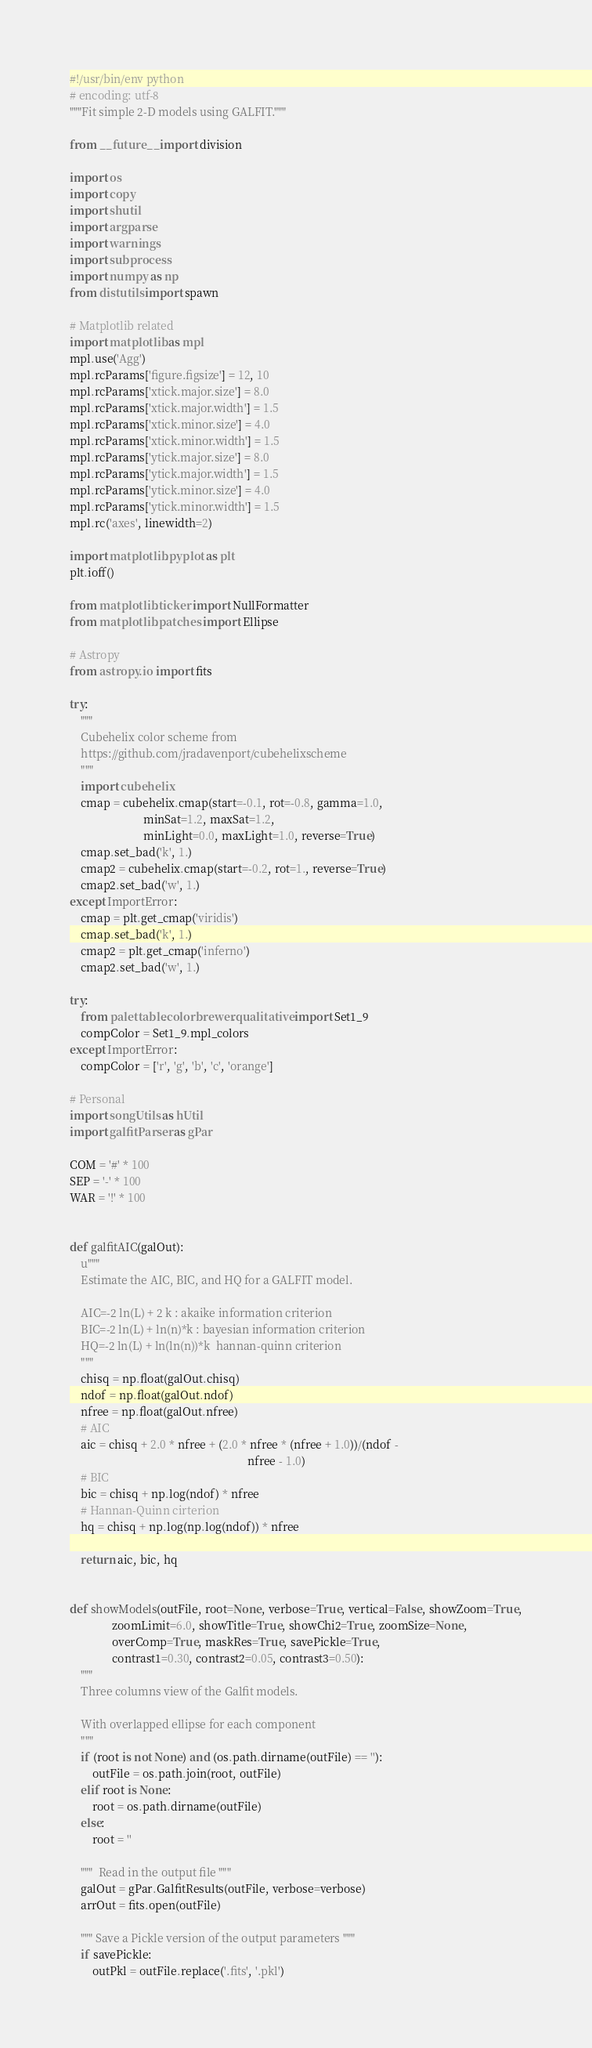<code> <loc_0><loc_0><loc_500><loc_500><_Python_>#!/usr/bin/env python
# encoding: utf-8
"""Fit simple 2-D models using GALFIT."""

from __future__ import division

import os
import copy
import shutil
import argparse
import warnings
import subprocess
import numpy as np
from distutils import spawn

# Matplotlib related
import matplotlib as mpl
mpl.use('Agg')
mpl.rcParams['figure.figsize'] = 12, 10
mpl.rcParams['xtick.major.size'] = 8.0
mpl.rcParams['xtick.major.width'] = 1.5
mpl.rcParams['xtick.minor.size'] = 4.0
mpl.rcParams['xtick.minor.width'] = 1.5
mpl.rcParams['ytick.major.size'] = 8.0
mpl.rcParams['ytick.major.width'] = 1.5
mpl.rcParams['ytick.minor.size'] = 4.0
mpl.rcParams['ytick.minor.width'] = 1.5
mpl.rc('axes', linewidth=2)

import matplotlib.pyplot as plt
plt.ioff()

from matplotlib.ticker import NullFormatter
from matplotlib.patches import Ellipse

# Astropy
from astropy.io import fits

try:
    """
    Cubehelix color scheme from
    https://github.com/jradavenport/cubehelixscheme
    """
    import cubehelix
    cmap = cubehelix.cmap(start=-0.1, rot=-0.8, gamma=1.0,
                          minSat=1.2, maxSat=1.2,
                          minLight=0.0, maxLight=1.0, reverse=True)
    cmap.set_bad('k', 1.)
    cmap2 = cubehelix.cmap(start=-0.2, rot=1., reverse=True)
    cmap2.set_bad('w', 1.)
except ImportError:
    cmap = plt.get_cmap('viridis')
    cmap.set_bad('k', 1.)
    cmap2 = plt.get_cmap('inferno')
    cmap2.set_bad('w', 1.)

try:
    from palettable.colorbrewer.qualitative import Set1_9
    compColor = Set1_9.mpl_colors
except ImportError:
    compColor = ['r', 'g', 'b', 'c', 'orange']

# Personal
import songUtils as hUtil
import galfitParser as gPar

COM = '#' * 100
SEP = '-' * 100
WAR = '!' * 100


def galfitAIC(galOut):
    u"""
    Estimate the AIC, BIC, and HQ for a GALFIT model.

    AIC=-2 ln(L) + 2 k : akaike information criterion
    BIC=-2 ln(L) + ln(n)*k : bayesian information criterion
    HQ=-2 ln(L) + ln(ln(n))*k  hannan-quinn criterion
    """
    chisq = np.float(galOut.chisq)
    ndof = np.float(galOut.ndof)
    nfree = np.float(galOut.nfree)
    # AIC
    aic = chisq + 2.0 * nfree + (2.0 * nfree * (nfree + 1.0))/(ndof -
                                                               nfree - 1.0)
    # BIC
    bic = chisq + np.log(ndof) * nfree
    # Hannan-Quinn cirterion
    hq = chisq + np.log(np.log(ndof)) * nfree

    return aic, bic, hq


def showModels(outFile, root=None, verbose=True, vertical=False, showZoom=True,
               zoomLimit=6.0, showTitle=True, showChi2=True, zoomSize=None,
               overComp=True, maskRes=True, savePickle=True,
               contrast1=0.30, contrast2=0.05, contrast3=0.50):
    """
    Three columns view of the Galfit models.

    With overlapped ellipse for each component
    """
    if (root is not None) and (os.path.dirname(outFile) == ''):
        outFile = os.path.join(root, outFile)
    elif root is None:
        root = os.path.dirname(outFile)
    else:
        root = ''

    """  Read in the output file """
    galOut = gPar.GalfitResults(outFile, verbose=verbose)
    arrOut = fits.open(outFile)

    """ Save a Pickle version of the output parameters """
    if savePickle:
        outPkl = outFile.replace('.fits', '.pkl')</code> 